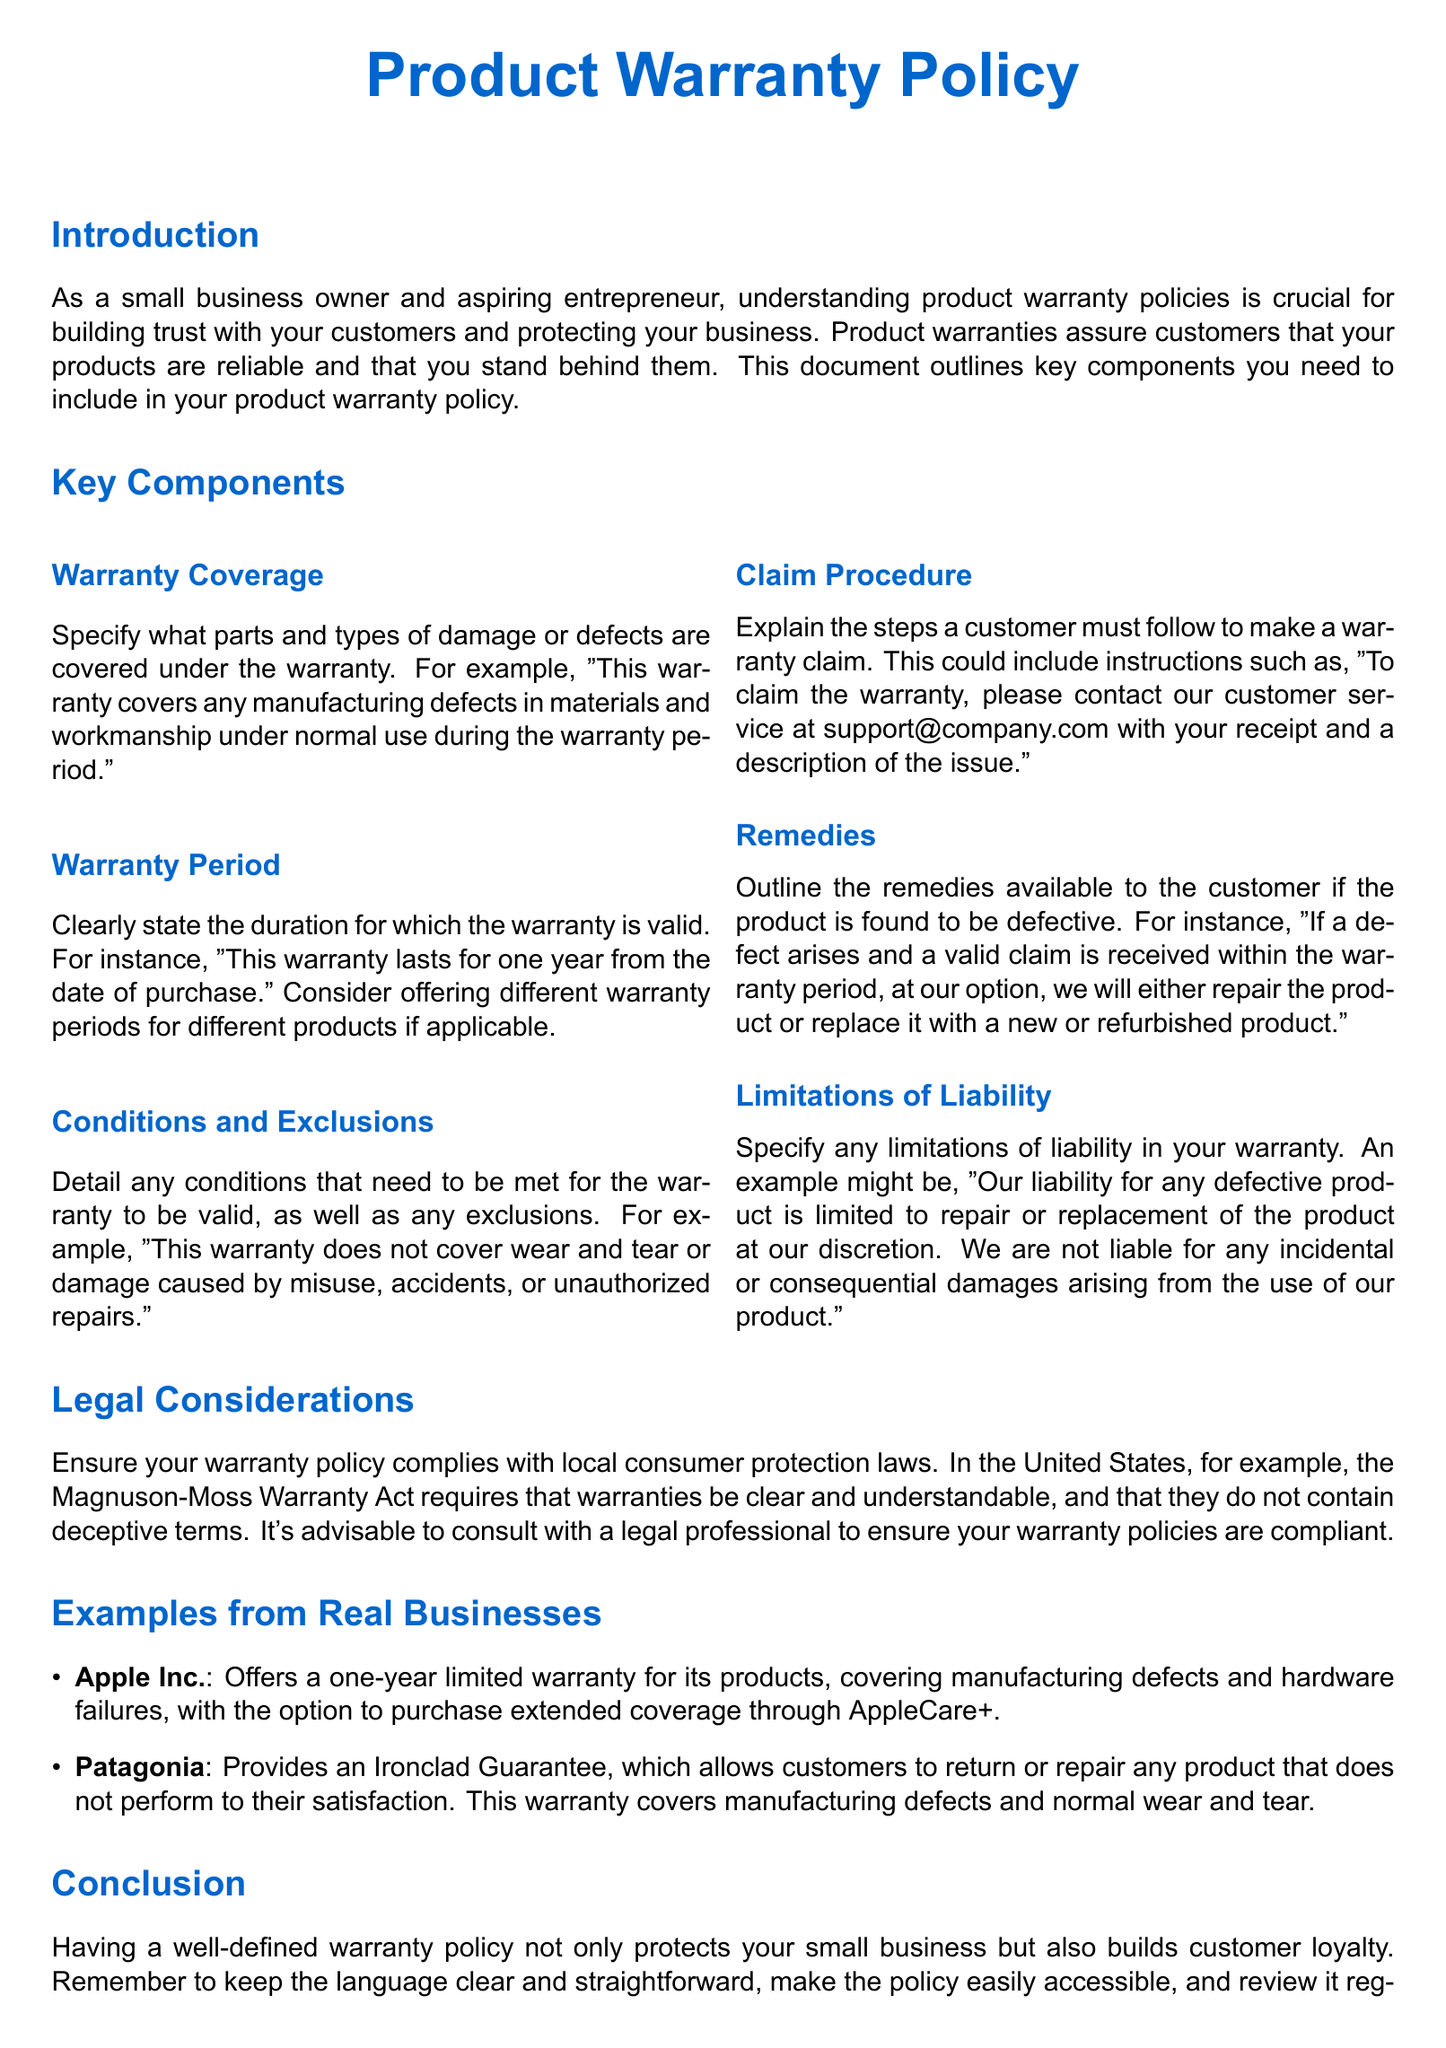what does the warranty cover? The document specifies that the warranty covers any manufacturing defects in materials and workmanship under normal use during the warranty period.
Answer: manufacturing defects what is the duration of the warranty? The document states that the warranty lasts for one year from the date of purchase.
Answer: one year which company provides an Ironclad Guarantee? The document mentions Patagonia as a company that provides an Ironclad Guarantee for its products.
Answer: Patagonia what procedure must customers follow to make a warranty claim? The document states that customers should contact customer service with their receipt and a description of the issue to make a warranty claim.
Answer: contact customer service what type of damages are not covered by the warranty? The document indicates that the warranty does not cover wear and tear or damage caused by misuse, accidents, or unauthorized repairs.
Answer: wear and tear what must a warranty policy comply with? The document emphasizes that a warranty policy must comply with local consumer protection laws, mentioning the Magnuson-Moss Warranty Act specifically for the United States.
Answer: local consumer protection laws what is a remedy available if a product is defective? The document states that if a defect arises and a valid claim is received, the company will either repair the product or replace it.
Answer: repair or replace who should business owners consult to ensure warranty compliance? The document advises business owners to consult with a legal professional to ensure warranty policies are compliant.
Answer: legal professional 